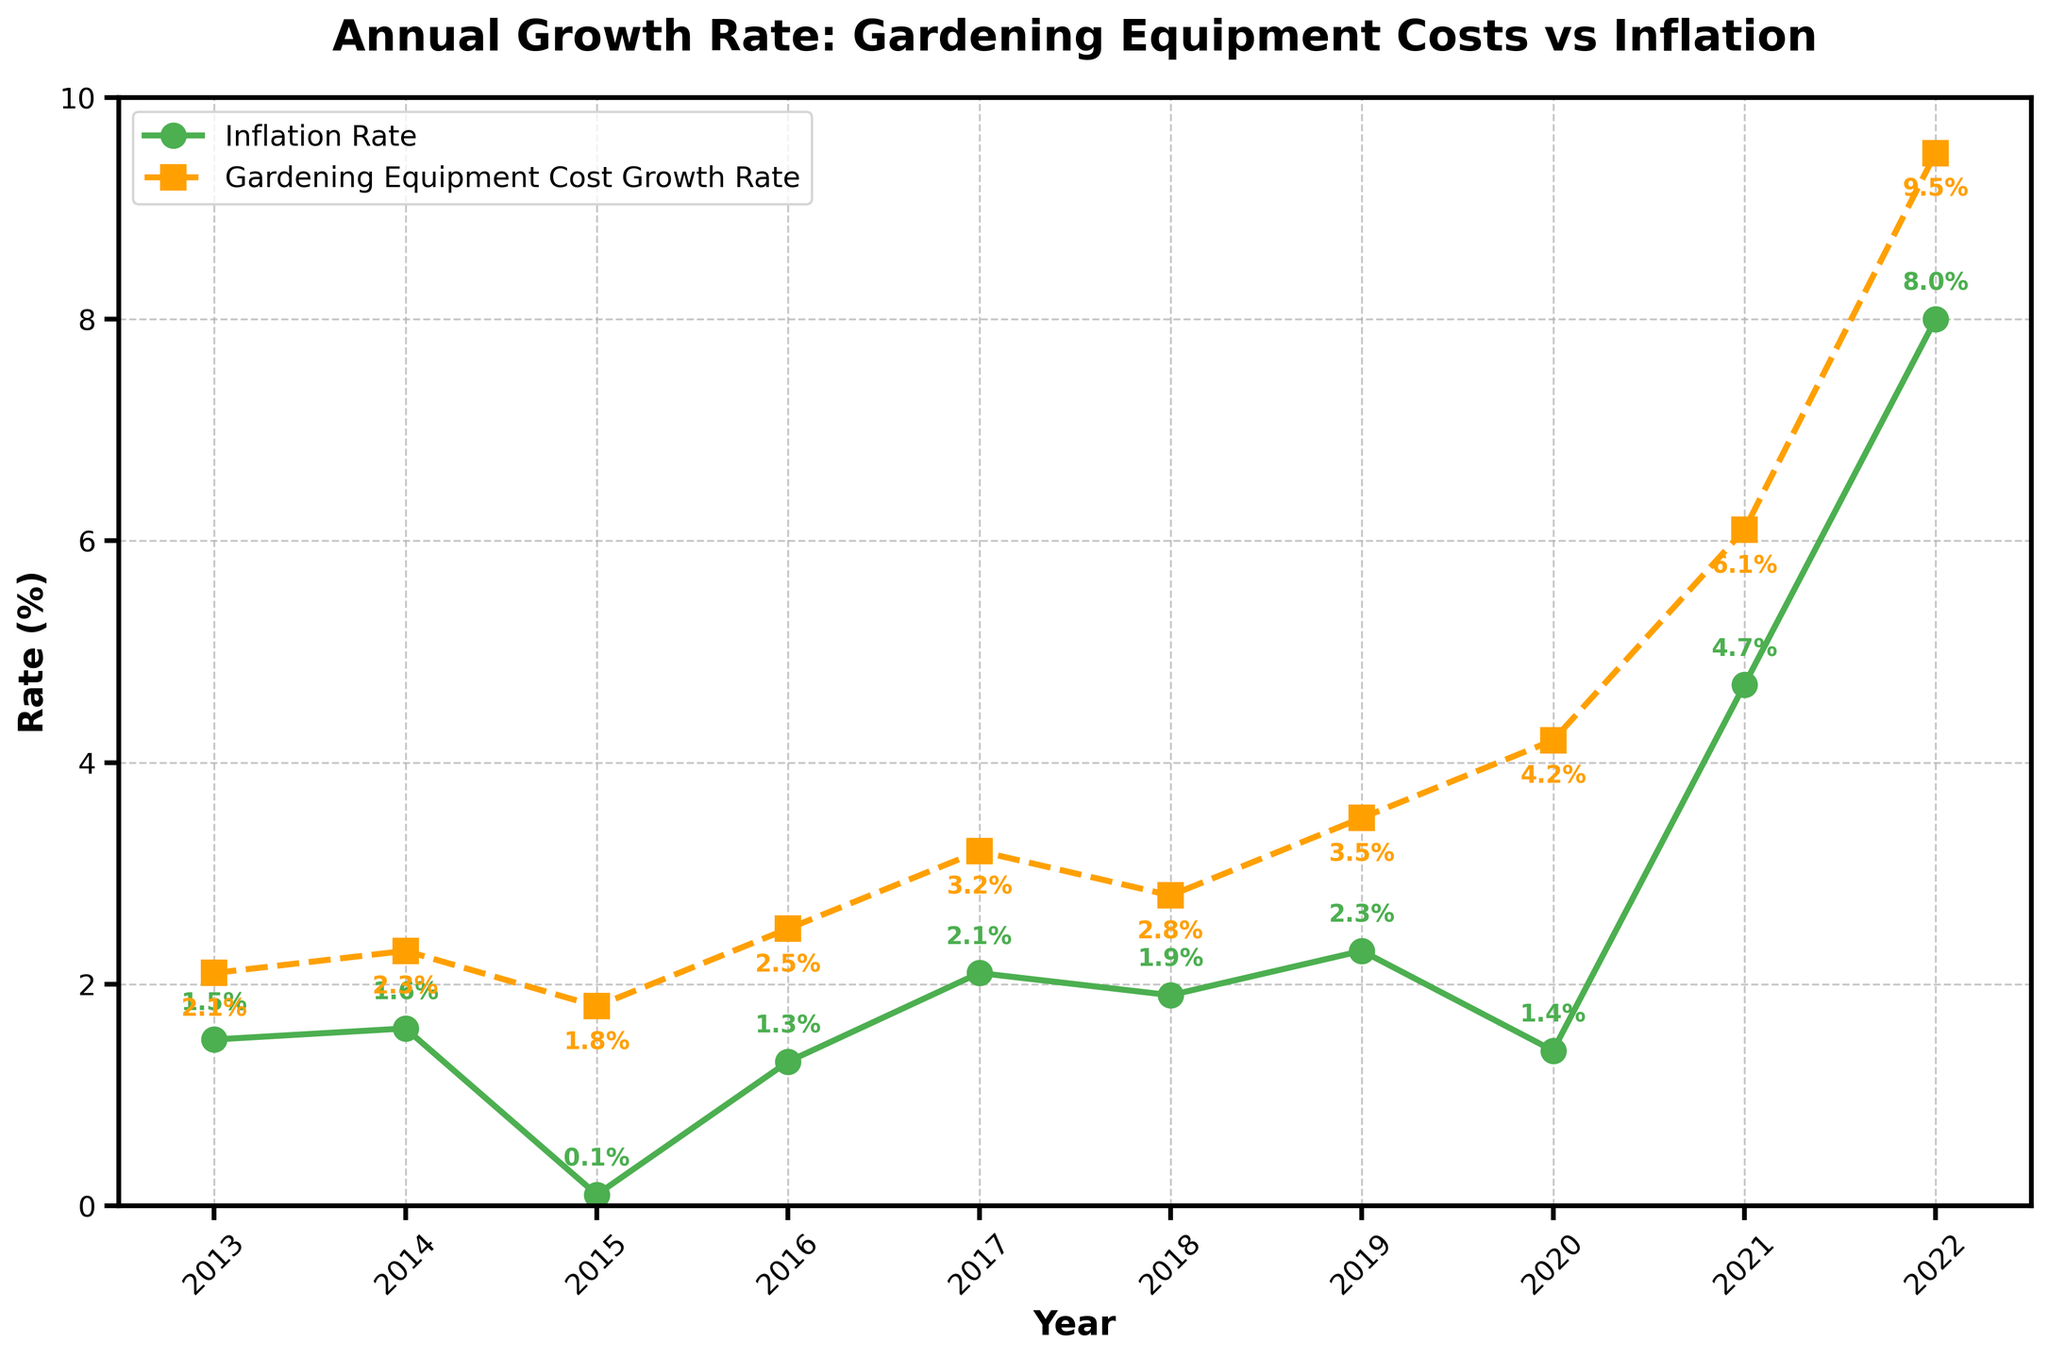What's the difference between the gardening equipment cost growth rate and the inflation rate in 2017? In 2017, the inflation rate is 2.1% and the gardening equipment cost growth rate is 3.2%. The difference is calculated as 3.2% - 2.1%.
Answer: 1.1% Which year shows the highest rate of inflation, and what is that rate? By looking at the plot, the highest point of the inflation rate curve is in 2022 at 8.0%.
Answer: 2022, 8.0% In which year was the gap between the gardening equipment cost growth rate and the inflation rate the largest, and what was that gap? To find the largest gap, the differences for each year need to be calculated. The largest gap is in 2022 with a difference of 9.5% - 8.0%.
Answer: 2022, 1.5% Is there any year where the inflation rate exceeds the gardening equipment cost growth rate? The plot shows that in every year, the gardening equipment cost growth rate is higher than the inflation rate.
Answer: No What's the average gardening equipment cost growth rate over the decade? The values are: 2.1, 2.3, 1.8, 2.5, 3.2, 2.8, 3.5, 4.2, 6.1, 9.5. Summing them results in 38.0. The average is 38.0 / 10.
Answer: 3.8% Which line color represents the inflation rate? By referring to the plot's legend and the line colors, the inflation rate is represented by the green line.
Answer: Green How does the inflation rate in 2020 compare to the gardening equipment cost growth rate in the same year? The inflation rate in 2020 is 1.4%, and the gardening equipment cost growth rate is 4.2%. To compare, 4.2% is greater than 1.4%.
Answer: Gardening equipment cost growth rate is higher Did the gardening equipment cost growth rate increase or decrease from 2014 to 2015? The value for 2014 is 2.3%, and for 2015, it is 1.8%. Since 1.8% is less than 2.3%, it decreased.
Answer: Decreased 